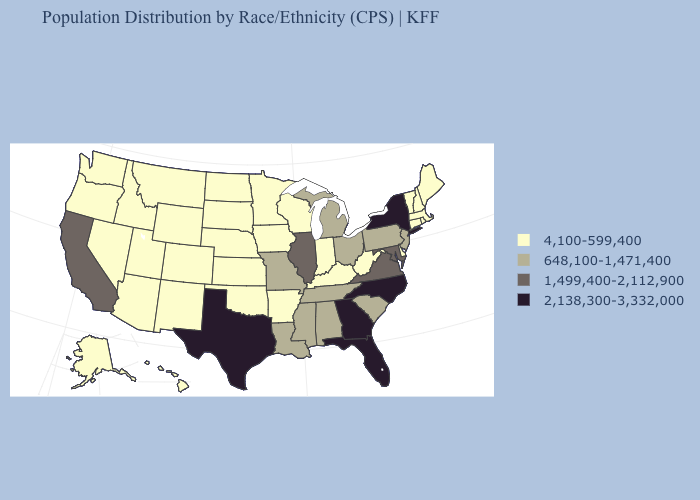What is the highest value in the USA?
Quick response, please. 2,138,300-3,332,000. How many symbols are there in the legend?
Short answer required. 4. What is the value of Kansas?
Be succinct. 4,100-599,400. Does New York have the highest value in the Northeast?
Short answer required. Yes. Among the states that border Texas , which have the highest value?
Be succinct. Louisiana. What is the value of Kansas?
Answer briefly. 4,100-599,400. Does New Jersey have the lowest value in the Northeast?
Keep it brief. No. Name the states that have a value in the range 1,499,400-2,112,900?
Answer briefly. California, Illinois, Maryland, Virginia. What is the highest value in states that border Iowa?
Keep it brief. 1,499,400-2,112,900. What is the value of Rhode Island?
Short answer required. 4,100-599,400. What is the highest value in the USA?
Quick response, please. 2,138,300-3,332,000. How many symbols are there in the legend?
Be succinct. 4. What is the lowest value in the South?
Answer briefly. 4,100-599,400. Does California have the lowest value in the West?
Quick response, please. No. 